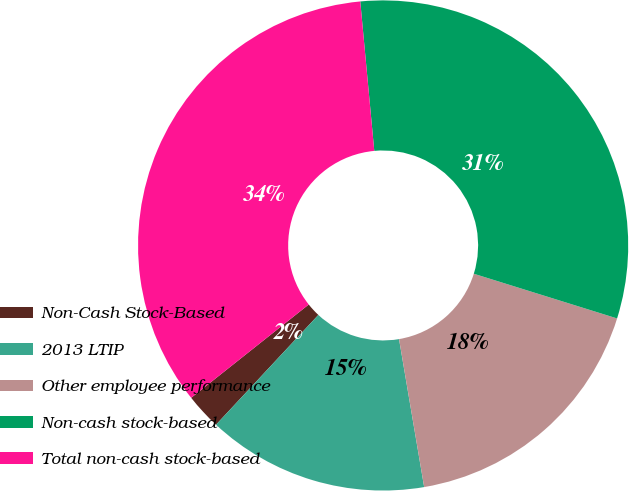<chart> <loc_0><loc_0><loc_500><loc_500><pie_chart><fcel>Non-Cash Stock-Based<fcel>2013 LTIP<fcel>Other employee performance<fcel>Non-cash stock-based<fcel>Total non-cash stock-based<nl><fcel>2.38%<fcel>14.62%<fcel>17.51%<fcel>31.3%<fcel>34.19%<nl></chart> 